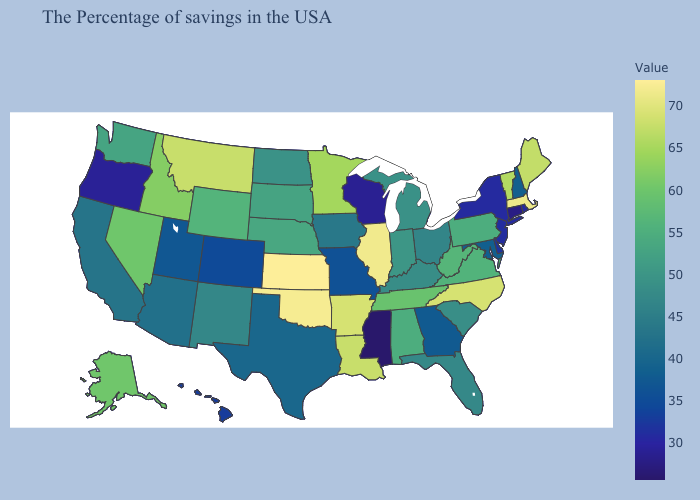Among the states that border Alabama , does Tennessee have the lowest value?
Quick response, please. No. Which states hav the highest value in the MidWest?
Be succinct. Kansas. Among the states that border Wyoming , does South Dakota have the lowest value?
Be succinct. No. Does Kansas have the highest value in the USA?
Concise answer only. Yes. Which states have the lowest value in the USA?
Quick response, please. Mississippi. Does Wyoming have the lowest value in the USA?
Quick response, please. No. 